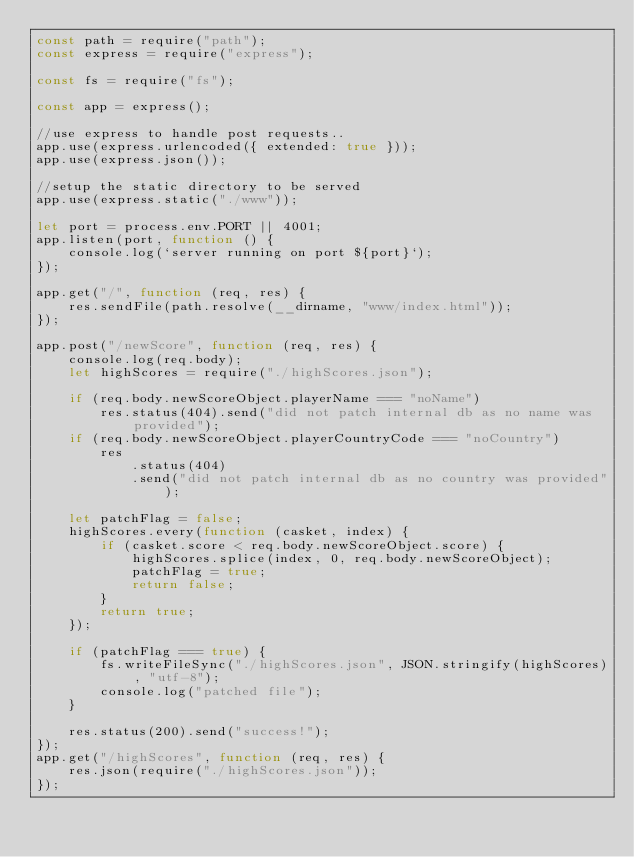<code> <loc_0><loc_0><loc_500><loc_500><_JavaScript_>const path = require("path");
const express = require("express");

const fs = require("fs");

const app = express();

//use express to handle post requests..
app.use(express.urlencoded({ extended: true }));
app.use(express.json());

//setup the static directory to be served
app.use(express.static("./www"));

let port = process.env.PORT || 4001;
app.listen(port, function () {
	console.log(`server running on port ${port}`);
});

app.get("/", function (req, res) {
	res.sendFile(path.resolve(__dirname, "www/index.html"));
});

app.post("/newScore", function (req, res) {
	console.log(req.body);
	let highScores = require("./highScores.json");

	if (req.body.newScoreObject.playerName === "noName")
		res.status(404).send("did not patch internal db as no name was provided");
	if (req.body.newScoreObject.playerCountryCode === "noCountry")
		res
			.status(404)
			.send("did not patch internal db as no country was provided");

	let patchFlag = false;
	highScores.every(function (casket, index) {
		if (casket.score < req.body.newScoreObject.score) {
			highScores.splice(index, 0, req.body.newScoreObject);
			patchFlag = true;
			return false;
		}
		return true;
	});

	if (patchFlag === true) {
		fs.writeFileSync("./highScores.json", JSON.stringify(highScores), "utf-8");
		console.log("patched file");
	}

	res.status(200).send("success!");
});
app.get("/highScores", function (req, res) {
	res.json(require("./highScores.json"));
});
</code> 